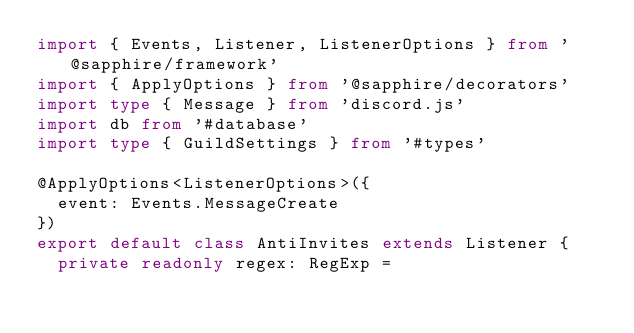<code> <loc_0><loc_0><loc_500><loc_500><_TypeScript_>import { Events, Listener, ListenerOptions } from '@sapphire/framework'
import { ApplyOptions } from '@sapphire/decorators'
import type { Message } from 'discord.js'
import db from '#database'
import type { GuildSettings } from '#types'

@ApplyOptions<ListenerOptions>({
  event: Events.MessageCreate
})
export default class AntiInvites extends Listener {
  private readonly regex: RegExp =</code> 